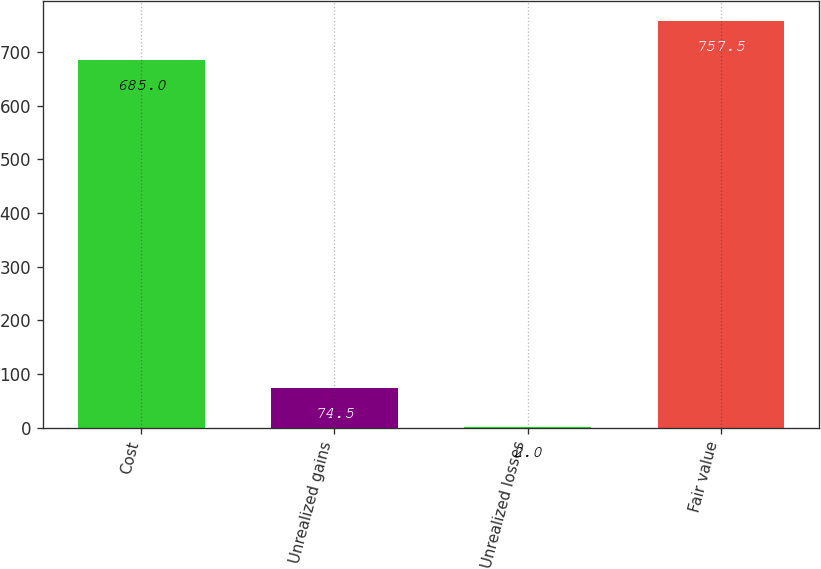Convert chart to OTSL. <chart><loc_0><loc_0><loc_500><loc_500><bar_chart><fcel>Cost<fcel>Unrealized gains<fcel>Unrealized losses<fcel>Fair value<nl><fcel>685<fcel>74.5<fcel>2<fcel>757.5<nl></chart> 